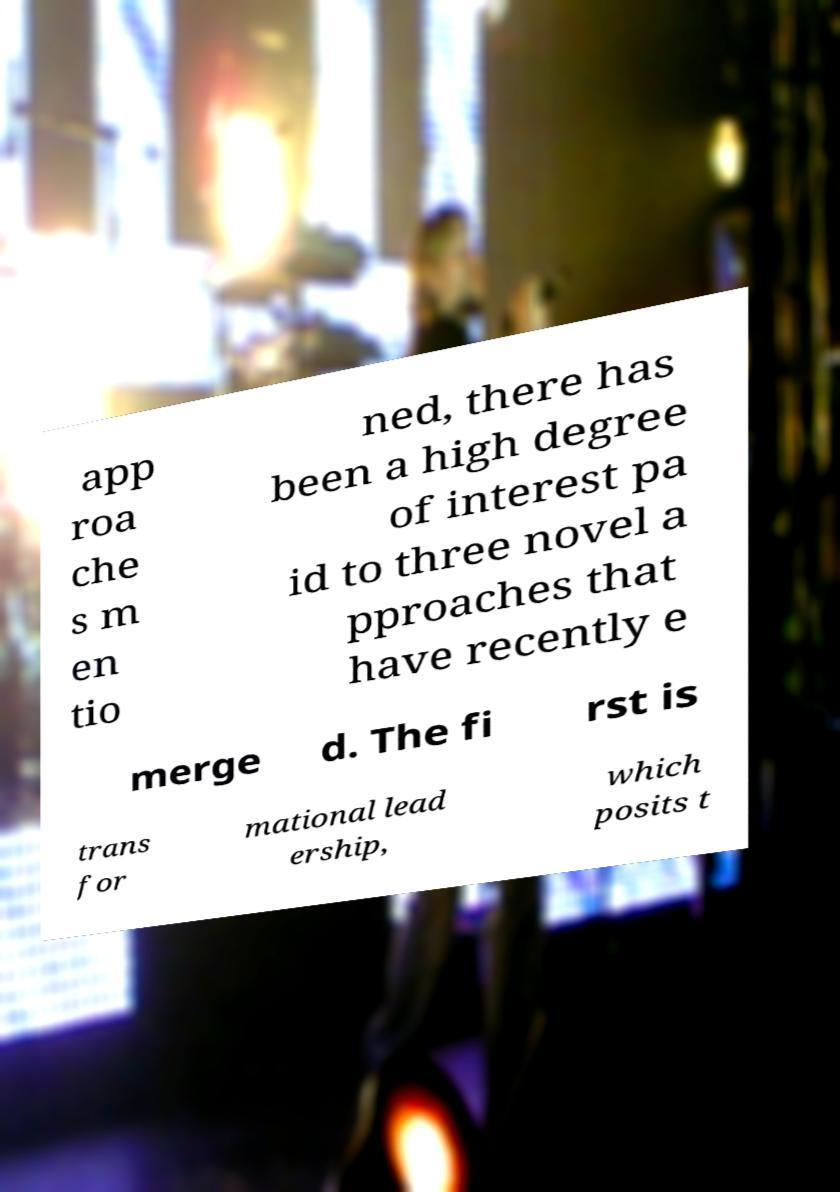Could you extract and type out the text from this image? app roa che s m en tio ned, there has been a high degree of interest pa id to three novel a pproaches that have recently e merge d. The fi rst is trans for mational lead ership, which posits t 